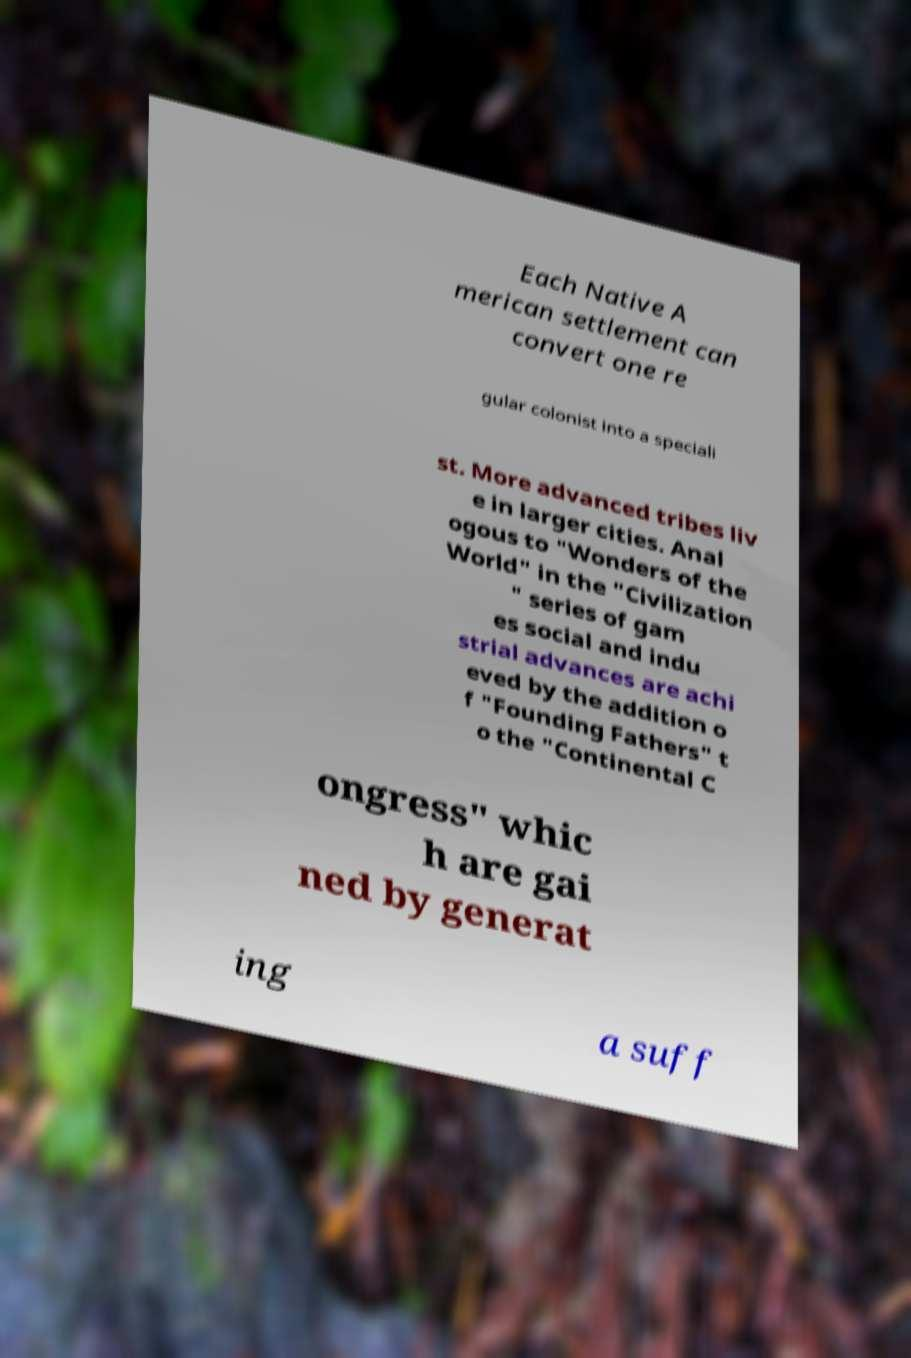There's text embedded in this image that I need extracted. Can you transcribe it verbatim? Each Native A merican settlement can convert one re gular colonist into a speciali st. More advanced tribes liv e in larger cities. Anal ogous to "Wonders of the World" in the "Civilization " series of gam es social and indu strial advances are achi eved by the addition o f "Founding Fathers" t o the "Continental C ongress" whic h are gai ned by generat ing a suff 